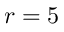Convert formula to latex. <formula><loc_0><loc_0><loc_500><loc_500>r = 5</formula> 